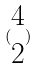<formula> <loc_0><loc_0><loc_500><loc_500>( \begin{matrix} 4 \\ 2 \end{matrix} )</formula> 